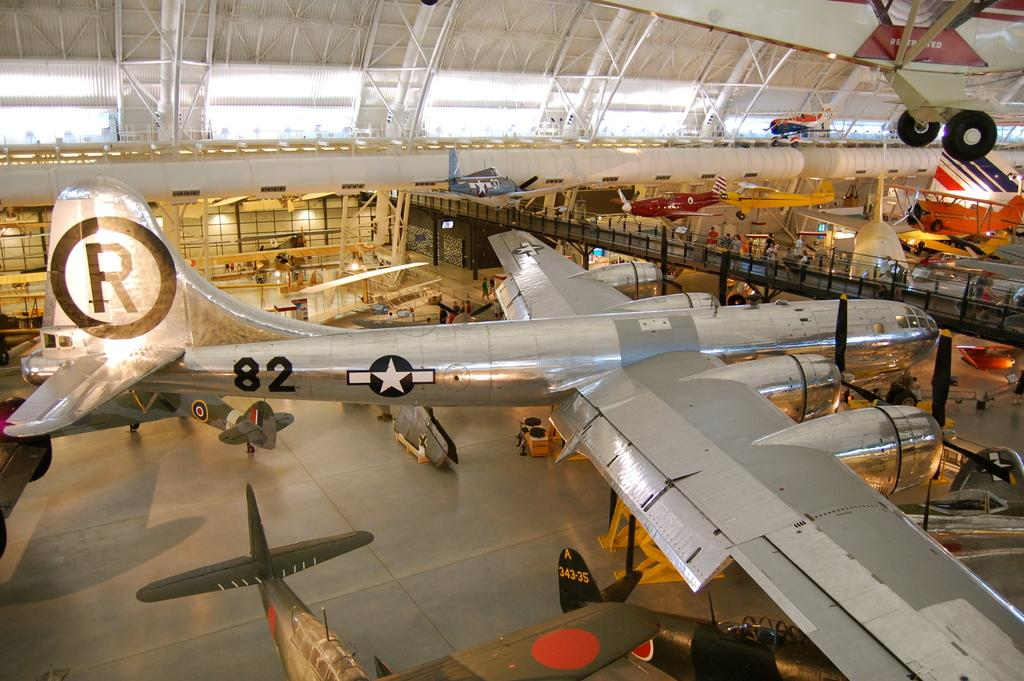Provide a one-sentence caption for the provided image. A plane in a large hangar has an R on it's tail and 82 on the side. 